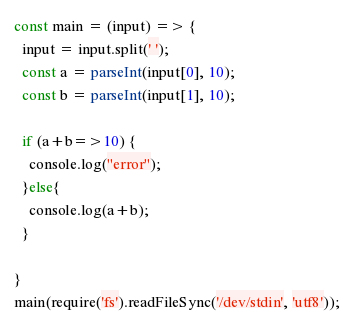<code> <loc_0><loc_0><loc_500><loc_500><_TypeScript_>const main = (input) => {
  input = input.split(' ');
  const a = parseInt(input[0], 10);
  const b = parseInt(input[1], 10);
  
  if (a+b=>10) {
    console.log("error");
  }else{
    console.log(a+b);
  }
  
}
main(require('fs').readFileSync('/dev/stdin', 'utf8'));</code> 